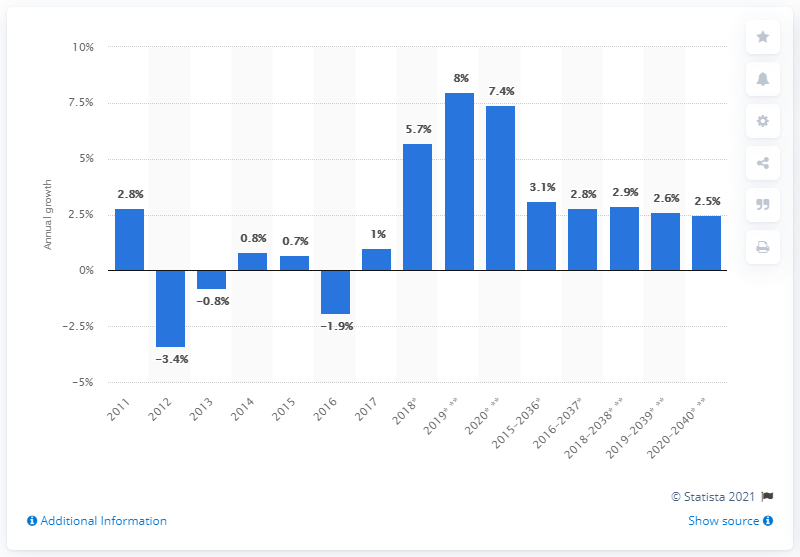Identify some key points in this picture. By 2040, it is projected that the revenue passenger miles will increase by 2.5 times compared to 2020 levels, signifying a significant growth in air travel demand. 